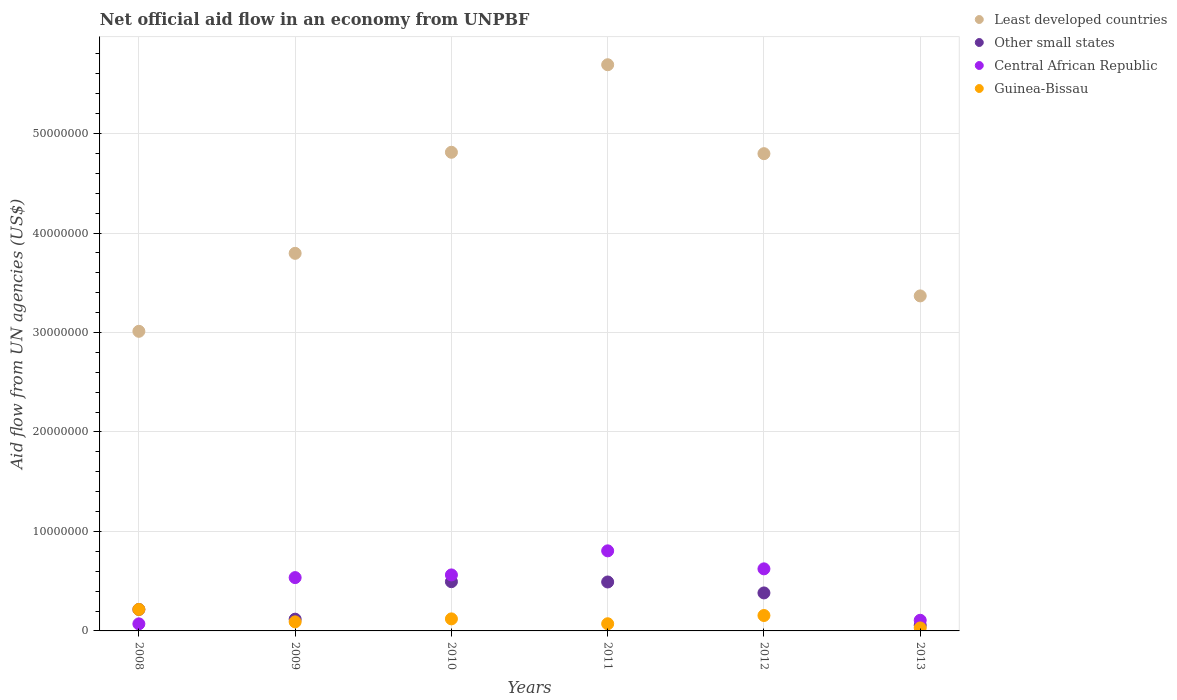What is the net official aid flow in Other small states in 2010?
Your answer should be very brief. 4.95e+06. Across all years, what is the maximum net official aid flow in Least developed countries?
Provide a succinct answer. 5.69e+07. Across all years, what is the minimum net official aid flow in Guinea-Bissau?
Offer a very short reply. 3.00e+05. In which year was the net official aid flow in Other small states minimum?
Give a very brief answer. 2013. What is the total net official aid flow in Guinea-Bissau in the graph?
Keep it short and to the point. 6.85e+06. What is the difference between the net official aid flow in Central African Republic in 2008 and that in 2012?
Offer a very short reply. -5.53e+06. What is the difference between the net official aid flow in Other small states in 2010 and the net official aid flow in Guinea-Bissau in 2009?
Your answer should be compact. 4.04e+06. What is the average net official aid flow in Other small states per year?
Offer a very short reply. 2.93e+06. In the year 2010, what is the difference between the net official aid flow in Least developed countries and net official aid flow in Central African Republic?
Your answer should be compact. 4.25e+07. What is the ratio of the net official aid flow in Guinea-Bissau in 2011 to that in 2012?
Keep it short and to the point. 0.46. Is the net official aid flow in Least developed countries in 2008 less than that in 2013?
Make the answer very short. Yes. What is the difference between the highest and the second highest net official aid flow in Least developed countries?
Give a very brief answer. 8.80e+06. What is the difference between the highest and the lowest net official aid flow in Least developed countries?
Your answer should be compact. 2.68e+07. In how many years, is the net official aid flow in Central African Republic greater than the average net official aid flow in Central African Republic taken over all years?
Offer a very short reply. 4. Is the sum of the net official aid flow in Guinea-Bissau in 2009 and 2013 greater than the maximum net official aid flow in Other small states across all years?
Keep it short and to the point. No. Is it the case that in every year, the sum of the net official aid flow in Central African Republic and net official aid flow in Other small states  is greater than the sum of net official aid flow in Least developed countries and net official aid flow in Guinea-Bissau?
Ensure brevity in your answer.  No. Does the net official aid flow in Least developed countries monotonically increase over the years?
Provide a short and direct response. No. Is the net official aid flow in Other small states strictly less than the net official aid flow in Guinea-Bissau over the years?
Keep it short and to the point. No. What is the difference between two consecutive major ticks on the Y-axis?
Ensure brevity in your answer.  1.00e+07. Are the values on the major ticks of Y-axis written in scientific E-notation?
Your answer should be very brief. No. How many legend labels are there?
Your answer should be very brief. 4. What is the title of the graph?
Provide a short and direct response. Net official aid flow in an economy from UNPBF. What is the label or title of the Y-axis?
Offer a terse response. Aid flow from UN agencies (US$). What is the Aid flow from UN agencies (US$) of Least developed countries in 2008?
Your answer should be compact. 3.01e+07. What is the Aid flow from UN agencies (US$) of Other small states in 2008?
Your answer should be compact. 2.16e+06. What is the Aid flow from UN agencies (US$) of Central African Republic in 2008?
Provide a succinct answer. 7.10e+05. What is the Aid flow from UN agencies (US$) in Guinea-Bissau in 2008?
Your answer should be compact. 2.16e+06. What is the Aid flow from UN agencies (US$) of Least developed countries in 2009?
Offer a very short reply. 3.80e+07. What is the Aid flow from UN agencies (US$) of Other small states in 2009?
Ensure brevity in your answer.  1.18e+06. What is the Aid flow from UN agencies (US$) of Central African Republic in 2009?
Keep it short and to the point. 5.36e+06. What is the Aid flow from UN agencies (US$) of Guinea-Bissau in 2009?
Keep it short and to the point. 9.10e+05. What is the Aid flow from UN agencies (US$) in Least developed countries in 2010?
Provide a succinct answer. 4.81e+07. What is the Aid flow from UN agencies (US$) in Other small states in 2010?
Provide a short and direct response. 4.95e+06. What is the Aid flow from UN agencies (US$) in Central African Republic in 2010?
Make the answer very short. 5.63e+06. What is the Aid flow from UN agencies (US$) in Guinea-Bissau in 2010?
Your answer should be compact. 1.21e+06. What is the Aid flow from UN agencies (US$) in Least developed countries in 2011?
Provide a short and direct response. 5.69e+07. What is the Aid flow from UN agencies (US$) of Other small states in 2011?
Give a very brief answer. 4.92e+06. What is the Aid flow from UN agencies (US$) in Central African Republic in 2011?
Keep it short and to the point. 8.05e+06. What is the Aid flow from UN agencies (US$) in Guinea-Bissau in 2011?
Offer a terse response. 7.20e+05. What is the Aid flow from UN agencies (US$) of Least developed countries in 2012?
Your response must be concise. 4.80e+07. What is the Aid flow from UN agencies (US$) in Other small states in 2012?
Offer a terse response. 3.82e+06. What is the Aid flow from UN agencies (US$) in Central African Republic in 2012?
Your answer should be very brief. 6.24e+06. What is the Aid flow from UN agencies (US$) of Guinea-Bissau in 2012?
Your answer should be very brief. 1.55e+06. What is the Aid flow from UN agencies (US$) of Least developed countries in 2013?
Keep it short and to the point. 3.37e+07. What is the Aid flow from UN agencies (US$) of Other small states in 2013?
Offer a terse response. 5.70e+05. What is the Aid flow from UN agencies (US$) of Central African Republic in 2013?
Give a very brief answer. 1.07e+06. Across all years, what is the maximum Aid flow from UN agencies (US$) in Least developed countries?
Offer a terse response. 5.69e+07. Across all years, what is the maximum Aid flow from UN agencies (US$) of Other small states?
Your response must be concise. 4.95e+06. Across all years, what is the maximum Aid flow from UN agencies (US$) in Central African Republic?
Your answer should be compact. 8.05e+06. Across all years, what is the maximum Aid flow from UN agencies (US$) in Guinea-Bissau?
Offer a terse response. 2.16e+06. Across all years, what is the minimum Aid flow from UN agencies (US$) of Least developed countries?
Keep it short and to the point. 3.01e+07. Across all years, what is the minimum Aid flow from UN agencies (US$) in Other small states?
Make the answer very short. 5.70e+05. Across all years, what is the minimum Aid flow from UN agencies (US$) in Central African Republic?
Your answer should be very brief. 7.10e+05. What is the total Aid flow from UN agencies (US$) of Least developed countries in the graph?
Keep it short and to the point. 2.55e+08. What is the total Aid flow from UN agencies (US$) in Other small states in the graph?
Give a very brief answer. 1.76e+07. What is the total Aid flow from UN agencies (US$) of Central African Republic in the graph?
Your answer should be compact. 2.71e+07. What is the total Aid flow from UN agencies (US$) in Guinea-Bissau in the graph?
Make the answer very short. 6.85e+06. What is the difference between the Aid flow from UN agencies (US$) of Least developed countries in 2008 and that in 2009?
Provide a short and direct response. -7.84e+06. What is the difference between the Aid flow from UN agencies (US$) in Other small states in 2008 and that in 2009?
Your answer should be very brief. 9.80e+05. What is the difference between the Aid flow from UN agencies (US$) of Central African Republic in 2008 and that in 2009?
Give a very brief answer. -4.65e+06. What is the difference between the Aid flow from UN agencies (US$) of Guinea-Bissau in 2008 and that in 2009?
Ensure brevity in your answer.  1.25e+06. What is the difference between the Aid flow from UN agencies (US$) of Least developed countries in 2008 and that in 2010?
Keep it short and to the point. -1.80e+07. What is the difference between the Aid flow from UN agencies (US$) in Other small states in 2008 and that in 2010?
Offer a terse response. -2.79e+06. What is the difference between the Aid flow from UN agencies (US$) in Central African Republic in 2008 and that in 2010?
Make the answer very short. -4.92e+06. What is the difference between the Aid flow from UN agencies (US$) of Guinea-Bissau in 2008 and that in 2010?
Provide a short and direct response. 9.50e+05. What is the difference between the Aid flow from UN agencies (US$) in Least developed countries in 2008 and that in 2011?
Offer a very short reply. -2.68e+07. What is the difference between the Aid flow from UN agencies (US$) in Other small states in 2008 and that in 2011?
Your answer should be compact. -2.76e+06. What is the difference between the Aid flow from UN agencies (US$) in Central African Republic in 2008 and that in 2011?
Your answer should be compact. -7.34e+06. What is the difference between the Aid flow from UN agencies (US$) of Guinea-Bissau in 2008 and that in 2011?
Provide a succinct answer. 1.44e+06. What is the difference between the Aid flow from UN agencies (US$) of Least developed countries in 2008 and that in 2012?
Offer a terse response. -1.79e+07. What is the difference between the Aid flow from UN agencies (US$) of Other small states in 2008 and that in 2012?
Provide a short and direct response. -1.66e+06. What is the difference between the Aid flow from UN agencies (US$) of Central African Republic in 2008 and that in 2012?
Give a very brief answer. -5.53e+06. What is the difference between the Aid flow from UN agencies (US$) in Least developed countries in 2008 and that in 2013?
Provide a short and direct response. -3.56e+06. What is the difference between the Aid flow from UN agencies (US$) of Other small states in 2008 and that in 2013?
Give a very brief answer. 1.59e+06. What is the difference between the Aid flow from UN agencies (US$) of Central African Republic in 2008 and that in 2013?
Make the answer very short. -3.60e+05. What is the difference between the Aid flow from UN agencies (US$) of Guinea-Bissau in 2008 and that in 2013?
Keep it short and to the point. 1.86e+06. What is the difference between the Aid flow from UN agencies (US$) of Least developed countries in 2009 and that in 2010?
Offer a very short reply. -1.02e+07. What is the difference between the Aid flow from UN agencies (US$) in Other small states in 2009 and that in 2010?
Give a very brief answer. -3.77e+06. What is the difference between the Aid flow from UN agencies (US$) of Least developed countries in 2009 and that in 2011?
Your response must be concise. -1.90e+07. What is the difference between the Aid flow from UN agencies (US$) in Other small states in 2009 and that in 2011?
Your answer should be very brief. -3.74e+06. What is the difference between the Aid flow from UN agencies (US$) of Central African Republic in 2009 and that in 2011?
Provide a short and direct response. -2.69e+06. What is the difference between the Aid flow from UN agencies (US$) of Guinea-Bissau in 2009 and that in 2011?
Give a very brief answer. 1.90e+05. What is the difference between the Aid flow from UN agencies (US$) of Least developed countries in 2009 and that in 2012?
Your response must be concise. -1.00e+07. What is the difference between the Aid flow from UN agencies (US$) of Other small states in 2009 and that in 2012?
Provide a succinct answer. -2.64e+06. What is the difference between the Aid flow from UN agencies (US$) in Central African Republic in 2009 and that in 2012?
Offer a terse response. -8.80e+05. What is the difference between the Aid flow from UN agencies (US$) in Guinea-Bissau in 2009 and that in 2012?
Your response must be concise. -6.40e+05. What is the difference between the Aid flow from UN agencies (US$) in Least developed countries in 2009 and that in 2013?
Provide a short and direct response. 4.28e+06. What is the difference between the Aid flow from UN agencies (US$) in Other small states in 2009 and that in 2013?
Provide a succinct answer. 6.10e+05. What is the difference between the Aid flow from UN agencies (US$) in Central African Republic in 2009 and that in 2013?
Your answer should be very brief. 4.29e+06. What is the difference between the Aid flow from UN agencies (US$) of Guinea-Bissau in 2009 and that in 2013?
Offer a terse response. 6.10e+05. What is the difference between the Aid flow from UN agencies (US$) in Least developed countries in 2010 and that in 2011?
Provide a succinct answer. -8.80e+06. What is the difference between the Aid flow from UN agencies (US$) of Central African Republic in 2010 and that in 2011?
Your answer should be very brief. -2.42e+06. What is the difference between the Aid flow from UN agencies (US$) of Guinea-Bissau in 2010 and that in 2011?
Provide a succinct answer. 4.90e+05. What is the difference between the Aid flow from UN agencies (US$) of Least developed countries in 2010 and that in 2012?
Offer a very short reply. 1.40e+05. What is the difference between the Aid flow from UN agencies (US$) in Other small states in 2010 and that in 2012?
Provide a succinct answer. 1.13e+06. What is the difference between the Aid flow from UN agencies (US$) of Central African Republic in 2010 and that in 2012?
Your response must be concise. -6.10e+05. What is the difference between the Aid flow from UN agencies (US$) of Guinea-Bissau in 2010 and that in 2012?
Keep it short and to the point. -3.40e+05. What is the difference between the Aid flow from UN agencies (US$) of Least developed countries in 2010 and that in 2013?
Offer a very short reply. 1.44e+07. What is the difference between the Aid flow from UN agencies (US$) in Other small states in 2010 and that in 2013?
Make the answer very short. 4.38e+06. What is the difference between the Aid flow from UN agencies (US$) in Central African Republic in 2010 and that in 2013?
Your response must be concise. 4.56e+06. What is the difference between the Aid flow from UN agencies (US$) in Guinea-Bissau in 2010 and that in 2013?
Your response must be concise. 9.10e+05. What is the difference between the Aid flow from UN agencies (US$) of Least developed countries in 2011 and that in 2012?
Your response must be concise. 8.94e+06. What is the difference between the Aid flow from UN agencies (US$) of Other small states in 2011 and that in 2012?
Make the answer very short. 1.10e+06. What is the difference between the Aid flow from UN agencies (US$) of Central African Republic in 2011 and that in 2012?
Offer a very short reply. 1.81e+06. What is the difference between the Aid flow from UN agencies (US$) of Guinea-Bissau in 2011 and that in 2012?
Your answer should be compact. -8.30e+05. What is the difference between the Aid flow from UN agencies (US$) in Least developed countries in 2011 and that in 2013?
Make the answer very short. 2.32e+07. What is the difference between the Aid flow from UN agencies (US$) in Other small states in 2011 and that in 2013?
Your answer should be compact. 4.35e+06. What is the difference between the Aid flow from UN agencies (US$) in Central African Republic in 2011 and that in 2013?
Your answer should be very brief. 6.98e+06. What is the difference between the Aid flow from UN agencies (US$) in Guinea-Bissau in 2011 and that in 2013?
Keep it short and to the point. 4.20e+05. What is the difference between the Aid flow from UN agencies (US$) of Least developed countries in 2012 and that in 2013?
Your response must be concise. 1.43e+07. What is the difference between the Aid flow from UN agencies (US$) of Other small states in 2012 and that in 2013?
Provide a short and direct response. 3.25e+06. What is the difference between the Aid flow from UN agencies (US$) of Central African Republic in 2012 and that in 2013?
Provide a succinct answer. 5.17e+06. What is the difference between the Aid flow from UN agencies (US$) in Guinea-Bissau in 2012 and that in 2013?
Provide a short and direct response. 1.25e+06. What is the difference between the Aid flow from UN agencies (US$) of Least developed countries in 2008 and the Aid flow from UN agencies (US$) of Other small states in 2009?
Provide a succinct answer. 2.89e+07. What is the difference between the Aid flow from UN agencies (US$) in Least developed countries in 2008 and the Aid flow from UN agencies (US$) in Central African Republic in 2009?
Provide a succinct answer. 2.48e+07. What is the difference between the Aid flow from UN agencies (US$) of Least developed countries in 2008 and the Aid flow from UN agencies (US$) of Guinea-Bissau in 2009?
Make the answer very short. 2.92e+07. What is the difference between the Aid flow from UN agencies (US$) of Other small states in 2008 and the Aid flow from UN agencies (US$) of Central African Republic in 2009?
Your response must be concise. -3.20e+06. What is the difference between the Aid flow from UN agencies (US$) in Other small states in 2008 and the Aid flow from UN agencies (US$) in Guinea-Bissau in 2009?
Your answer should be compact. 1.25e+06. What is the difference between the Aid flow from UN agencies (US$) in Least developed countries in 2008 and the Aid flow from UN agencies (US$) in Other small states in 2010?
Your response must be concise. 2.52e+07. What is the difference between the Aid flow from UN agencies (US$) of Least developed countries in 2008 and the Aid flow from UN agencies (US$) of Central African Republic in 2010?
Your answer should be very brief. 2.45e+07. What is the difference between the Aid flow from UN agencies (US$) of Least developed countries in 2008 and the Aid flow from UN agencies (US$) of Guinea-Bissau in 2010?
Offer a very short reply. 2.89e+07. What is the difference between the Aid flow from UN agencies (US$) in Other small states in 2008 and the Aid flow from UN agencies (US$) in Central African Republic in 2010?
Offer a very short reply. -3.47e+06. What is the difference between the Aid flow from UN agencies (US$) of Other small states in 2008 and the Aid flow from UN agencies (US$) of Guinea-Bissau in 2010?
Offer a terse response. 9.50e+05. What is the difference between the Aid flow from UN agencies (US$) in Central African Republic in 2008 and the Aid flow from UN agencies (US$) in Guinea-Bissau in 2010?
Keep it short and to the point. -5.00e+05. What is the difference between the Aid flow from UN agencies (US$) in Least developed countries in 2008 and the Aid flow from UN agencies (US$) in Other small states in 2011?
Offer a terse response. 2.52e+07. What is the difference between the Aid flow from UN agencies (US$) in Least developed countries in 2008 and the Aid flow from UN agencies (US$) in Central African Republic in 2011?
Offer a very short reply. 2.21e+07. What is the difference between the Aid flow from UN agencies (US$) of Least developed countries in 2008 and the Aid flow from UN agencies (US$) of Guinea-Bissau in 2011?
Provide a short and direct response. 2.94e+07. What is the difference between the Aid flow from UN agencies (US$) in Other small states in 2008 and the Aid flow from UN agencies (US$) in Central African Republic in 2011?
Keep it short and to the point. -5.89e+06. What is the difference between the Aid flow from UN agencies (US$) of Other small states in 2008 and the Aid flow from UN agencies (US$) of Guinea-Bissau in 2011?
Give a very brief answer. 1.44e+06. What is the difference between the Aid flow from UN agencies (US$) of Central African Republic in 2008 and the Aid flow from UN agencies (US$) of Guinea-Bissau in 2011?
Your response must be concise. -10000. What is the difference between the Aid flow from UN agencies (US$) of Least developed countries in 2008 and the Aid flow from UN agencies (US$) of Other small states in 2012?
Make the answer very short. 2.63e+07. What is the difference between the Aid flow from UN agencies (US$) in Least developed countries in 2008 and the Aid flow from UN agencies (US$) in Central African Republic in 2012?
Offer a very short reply. 2.39e+07. What is the difference between the Aid flow from UN agencies (US$) of Least developed countries in 2008 and the Aid flow from UN agencies (US$) of Guinea-Bissau in 2012?
Your answer should be very brief. 2.86e+07. What is the difference between the Aid flow from UN agencies (US$) in Other small states in 2008 and the Aid flow from UN agencies (US$) in Central African Republic in 2012?
Offer a terse response. -4.08e+06. What is the difference between the Aid flow from UN agencies (US$) of Other small states in 2008 and the Aid flow from UN agencies (US$) of Guinea-Bissau in 2012?
Ensure brevity in your answer.  6.10e+05. What is the difference between the Aid flow from UN agencies (US$) of Central African Republic in 2008 and the Aid flow from UN agencies (US$) of Guinea-Bissau in 2012?
Make the answer very short. -8.40e+05. What is the difference between the Aid flow from UN agencies (US$) in Least developed countries in 2008 and the Aid flow from UN agencies (US$) in Other small states in 2013?
Your answer should be compact. 2.96e+07. What is the difference between the Aid flow from UN agencies (US$) of Least developed countries in 2008 and the Aid flow from UN agencies (US$) of Central African Republic in 2013?
Your answer should be compact. 2.90e+07. What is the difference between the Aid flow from UN agencies (US$) in Least developed countries in 2008 and the Aid flow from UN agencies (US$) in Guinea-Bissau in 2013?
Offer a terse response. 2.98e+07. What is the difference between the Aid flow from UN agencies (US$) in Other small states in 2008 and the Aid flow from UN agencies (US$) in Central African Republic in 2013?
Ensure brevity in your answer.  1.09e+06. What is the difference between the Aid flow from UN agencies (US$) of Other small states in 2008 and the Aid flow from UN agencies (US$) of Guinea-Bissau in 2013?
Provide a succinct answer. 1.86e+06. What is the difference between the Aid flow from UN agencies (US$) in Central African Republic in 2008 and the Aid flow from UN agencies (US$) in Guinea-Bissau in 2013?
Your answer should be compact. 4.10e+05. What is the difference between the Aid flow from UN agencies (US$) in Least developed countries in 2009 and the Aid flow from UN agencies (US$) in Other small states in 2010?
Provide a succinct answer. 3.30e+07. What is the difference between the Aid flow from UN agencies (US$) of Least developed countries in 2009 and the Aid flow from UN agencies (US$) of Central African Republic in 2010?
Give a very brief answer. 3.23e+07. What is the difference between the Aid flow from UN agencies (US$) of Least developed countries in 2009 and the Aid flow from UN agencies (US$) of Guinea-Bissau in 2010?
Give a very brief answer. 3.68e+07. What is the difference between the Aid flow from UN agencies (US$) of Other small states in 2009 and the Aid flow from UN agencies (US$) of Central African Republic in 2010?
Your answer should be very brief. -4.45e+06. What is the difference between the Aid flow from UN agencies (US$) of Central African Republic in 2009 and the Aid flow from UN agencies (US$) of Guinea-Bissau in 2010?
Offer a very short reply. 4.15e+06. What is the difference between the Aid flow from UN agencies (US$) in Least developed countries in 2009 and the Aid flow from UN agencies (US$) in Other small states in 2011?
Your answer should be very brief. 3.30e+07. What is the difference between the Aid flow from UN agencies (US$) in Least developed countries in 2009 and the Aid flow from UN agencies (US$) in Central African Republic in 2011?
Make the answer very short. 2.99e+07. What is the difference between the Aid flow from UN agencies (US$) of Least developed countries in 2009 and the Aid flow from UN agencies (US$) of Guinea-Bissau in 2011?
Provide a succinct answer. 3.72e+07. What is the difference between the Aid flow from UN agencies (US$) in Other small states in 2009 and the Aid flow from UN agencies (US$) in Central African Republic in 2011?
Provide a succinct answer. -6.87e+06. What is the difference between the Aid flow from UN agencies (US$) of Other small states in 2009 and the Aid flow from UN agencies (US$) of Guinea-Bissau in 2011?
Your answer should be compact. 4.60e+05. What is the difference between the Aid flow from UN agencies (US$) of Central African Republic in 2009 and the Aid flow from UN agencies (US$) of Guinea-Bissau in 2011?
Offer a terse response. 4.64e+06. What is the difference between the Aid flow from UN agencies (US$) of Least developed countries in 2009 and the Aid flow from UN agencies (US$) of Other small states in 2012?
Provide a short and direct response. 3.41e+07. What is the difference between the Aid flow from UN agencies (US$) of Least developed countries in 2009 and the Aid flow from UN agencies (US$) of Central African Republic in 2012?
Your answer should be compact. 3.17e+07. What is the difference between the Aid flow from UN agencies (US$) of Least developed countries in 2009 and the Aid flow from UN agencies (US$) of Guinea-Bissau in 2012?
Give a very brief answer. 3.64e+07. What is the difference between the Aid flow from UN agencies (US$) of Other small states in 2009 and the Aid flow from UN agencies (US$) of Central African Republic in 2012?
Give a very brief answer. -5.06e+06. What is the difference between the Aid flow from UN agencies (US$) in Other small states in 2009 and the Aid flow from UN agencies (US$) in Guinea-Bissau in 2012?
Make the answer very short. -3.70e+05. What is the difference between the Aid flow from UN agencies (US$) in Central African Republic in 2009 and the Aid flow from UN agencies (US$) in Guinea-Bissau in 2012?
Your response must be concise. 3.81e+06. What is the difference between the Aid flow from UN agencies (US$) in Least developed countries in 2009 and the Aid flow from UN agencies (US$) in Other small states in 2013?
Make the answer very short. 3.74e+07. What is the difference between the Aid flow from UN agencies (US$) of Least developed countries in 2009 and the Aid flow from UN agencies (US$) of Central African Republic in 2013?
Ensure brevity in your answer.  3.69e+07. What is the difference between the Aid flow from UN agencies (US$) in Least developed countries in 2009 and the Aid flow from UN agencies (US$) in Guinea-Bissau in 2013?
Give a very brief answer. 3.77e+07. What is the difference between the Aid flow from UN agencies (US$) of Other small states in 2009 and the Aid flow from UN agencies (US$) of Central African Republic in 2013?
Offer a very short reply. 1.10e+05. What is the difference between the Aid flow from UN agencies (US$) in Other small states in 2009 and the Aid flow from UN agencies (US$) in Guinea-Bissau in 2013?
Offer a very short reply. 8.80e+05. What is the difference between the Aid flow from UN agencies (US$) of Central African Republic in 2009 and the Aid flow from UN agencies (US$) of Guinea-Bissau in 2013?
Your response must be concise. 5.06e+06. What is the difference between the Aid flow from UN agencies (US$) of Least developed countries in 2010 and the Aid flow from UN agencies (US$) of Other small states in 2011?
Your response must be concise. 4.32e+07. What is the difference between the Aid flow from UN agencies (US$) of Least developed countries in 2010 and the Aid flow from UN agencies (US$) of Central African Republic in 2011?
Ensure brevity in your answer.  4.01e+07. What is the difference between the Aid flow from UN agencies (US$) in Least developed countries in 2010 and the Aid flow from UN agencies (US$) in Guinea-Bissau in 2011?
Your answer should be very brief. 4.74e+07. What is the difference between the Aid flow from UN agencies (US$) of Other small states in 2010 and the Aid flow from UN agencies (US$) of Central African Republic in 2011?
Offer a very short reply. -3.10e+06. What is the difference between the Aid flow from UN agencies (US$) of Other small states in 2010 and the Aid flow from UN agencies (US$) of Guinea-Bissau in 2011?
Your response must be concise. 4.23e+06. What is the difference between the Aid flow from UN agencies (US$) in Central African Republic in 2010 and the Aid flow from UN agencies (US$) in Guinea-Bissau in 2011?
Your answer should be compact. 4.91e+06. What is the difference between the Aid flow from UN agencies (US$) of Least developed countries in 2010 and the Aid flow from UN agencies (US$) of Other small states in 2012?
Your answer should be compact. 4.43e+07. What is the difference between the Aid flow from UN agencies (US$) of Least developed countries in 2010 and the Aid flow from UN agencies (US$) of Central African Republic in 2012?
Offer a very short reply. 4.19e+07. What is the difference between the Aid flow from UN agencies (US$) of Least developed countries in 2010 and the Aid flow from UN agencies (US$) of Guinea-Bissau in 2012?
Offer a terse response. 4.66e+07. What is the difference between the Aid flow from UN agencies (US$) of Other small states in 2010 and the Aid flow from UN agencies (US$) of Central African Republic in 2012?
Offer a very short reply. -1.29e+06. What is the difference between the Aid flow from UN agencies (US$) in Other small states in 2010 and the Aid flow from UN agencies (US$) in Guinea-Bissau in 2012?
Keep it short and to the point. 3.40e+06. What is the difference between the Aid flow from UN agencies (US$) in Central African Republic in 2010 and the Aid flow from UN agencies (US$) in Guinea-Bissau in 2012?
Offer a terse response. 4.08e+06. What is the difference between the Aid flow from UN agencies (US$) in Least developed countries in 2010 and the Aid flow from UN agencies (US$) in Other small states in 2013?
Offer a terse response. 4.76e+07. What is the difference between the Aid flow from UN agencies (US$) of Least developed countries in 2010 and the Aid flow from UN agencies (US$) of Central African Republic in 2013?
Provide a succinct answer. 4.70e+07. What is the difference between the Aid flow from UN agencies (US$) in Least developed countries in 2010 and the Aid flow from UN agencies (US$) in Guinea-Bissau in 2013?
Provide a short and direct response. 4.78e+07. What is the difference between the Aid flow from UN agencies (US$) of Other small states in 2010 and the Aid flow from UN agencies (US$) of Central African Republic in 2013?
Provide a short and direct response. 3.88e+06. What is the difference between the Aid flow from UN agencies (US$) in Other small states in 2010 and the Aid flow from UN agencies (US$) in Guinea-Bissau in 2013?
Offer a very short reply. 4.65e+06. What is the difference between the Aid flow from UN agencies (US$) in Central African Republic in 2010 and the Aid flow from UN agencies (US$) in Guinea-Bissau in 2013?
Your answer should be very brief. 5.33e+06. What is the difference between the Aid flow from UN agencies (US$) of Least developed countries in 2011 and the Aid flow from UN agencies (US$) of Other small states in 2012?
Offer a terse response. 5.31e+07. What is the difference between the Aid flow from UN agencies (US$) in Least developed countries in 2011 and the Aid flow from UN agencies (US$) in Central African Republic in 2012?
Offer a very short reply. 5.07e+07. What is the difference between the Aid flow from UN agencies (US$) of Least developed countries in 2011 and the Aid flow from UN agencies (US$) of Guinea-Bissau in 2012?
Your answer should be compact. 5.54e+07. What is the difference between the Aid flow from UN agencies (US$) in Other small states in 2011 and the Aid flow from UN agencies (US$) in Central African Republic in 2012?
Offer a terse response. -1.32e+06. What is the difference between the Aid flow from UN agencies (US$) of Other small states in 2011 and the Aid flow from UN agencies (US$) of Guinea-Bissau in 2012?
Your answer should be compact. 3.37e+06. What is the difference between the Aid flow from UN agencies (US$) in Central African Republic in 2011 and the Aid flow from UN agencies (US$) in Guinea-Bissau in 2012?
Give a very brief answer. 6.50e+06. What is the difference between the Aid flow from UN agencies (US$) of Least developed countries in 2011 and the Aid flow from UN agencies (US$) of Other small states in 2013?
Provide a short and direct response. 5.64e+07. What is the difference between the Aid flow from UN agencies (US$) of Least developed countries in 2011 and the Aid flow from UN agencies (US$) of Central African Republic in 2013?
Offer a terse response. 5.58e+07. What is the difference between the Aid flow from UN agencies (US$) in Least developed countries in 2011 and the Aid flow from UN agencies (US$) in Guinea-Bissau in 2013?
Ensure brevity in your answer.  5.66e+07. What is the difference between the Aid flow from UN agencies (US$) in Other small states in 2011 and the Aid flow from UN agencies (US$) in Central African Republic in 2013?
Offer a very short reply. 3.85e+06. What is the difference between the Aid flow from UN agencies (US$) in Other small states in 2011 and the Aid flow from UN agencies (US$) in Guinea-Bissau in 2013?
Keep it short and to the point. 4.62e+06. What is the difference between the Aid flow from UN agencies (US$) in Central African Republic in 2011 and the Aid flow from UN agencies (US$) in Guinea-Bissau in 2013?
Keep it short and to the point. 7.75e+06. What is the difference between the Aid flow from UN agencies (US$) of Least developed countries in 2012 and the Aid flow from UN agencies (US$) of Other small states in 2013?
Your answer should be compact. 4.74e+07. What is the difference between the Aid flow from UN agencies (US$) in Least developed countries in 2012 and the Aid flow from UN agencies (US$) in Central African Republic in 2013?
Your response must be concise. 4.69e+07. What is the difference between the Aid flow from UN agencies (US$) of Least developed countries in 2012 and the Aid flow from UN agencies (US$) of Guinea-Bissau in 2013?
Your response must be concise. 4.77e+07. What is the difference between the Aid flow from UN agencies (US$) of Other small states in 2012 and the Aid flow from UN agencies (US$) of Central African Republic in 2013?
Provide a succinct answer. 2.75e+06. What is the difference between the Aid flow from UN agencies (US$) in Other small states in 2012 and the Aid flow from UN agencies (US$) in Guinea-Bissau in 2013?
Provide a succinct answer. 3.52e+06. What is the difference between the Aid flow from UN agencies (US$) in Central African Republic in 2012 and the Aid flow from UN agencies (US$) in Guinea-Bissau in 2013?
Your response must be concise. 5.94e+06. What is the average Aid flow from UN agencies (US$) of Least developed countries per year?
Provide a short and direct response. 4.25e+07. What is the average Aid flow from UN agencies (US$) in Other small states per year?
Your answer should be very brief. 2.93e+06. What is the average Aid flow from UN agencies (US$) in Central African Republic per year?
Keep it short and to the point. 4.51e+06. What is the average Aid flow from UN agencies (US$) of Guinea-Bissau per year?
Offer a terse response. 1.14e+06. In the year 2008, what is the difference between the Aid flow from UN agencies (US$) of Least developed countries and Aid flow from UN agencies (US$) of Other small states?
Ensure brevity in your answer.  2.80e+07. In the year 2008, what is the difference between the Aid flow from UN agencies (US$) in Least developed countries and Aid flow from UN agencies (US$) in Central African Republic?
Your response must be concise. 2.94e+07. In the year 2008, what is the difference between the Aid flow from UN agencies (US$) of Least developed countries and Aid flow from UN agencies (US$) of Guinea-Bissau?
Give a very brief answer. 2.80e+07. In the year 2008, what is the difference between the Aid flow from UN agencies (US$) in Other small states and Aid flow from UN agencies (US$) in Central African Republic?
Keep it short and to the point. 1.45e+06. In the year 2008, what is the difference between the Aid flow from UN agencies (US$) in Other small states and Aid flow from UN agencies (US$) in Guinea-Bissau?
Your response must be concise. 0. In the year 2008, what is the difference between the Aid flow from UN agencies (US$) in Central African Republic and Aid flow from UN agencies (US$) in Guinea-Bissau?
Your response must be concise. -1.45e+06. In the year 2009, what is the difference between the Aid flow from UN agencies (US$) of Least developed countries and Aid flow from UN agencies (US$) of Other small states?
Your answer should be very brief. 3.68e+07. In the year 2009, what is the difference between the Aid flow from UN agencies (US$) in Least developed countries and Aid flow from UN agencies (US$) in Central African Republic?
Offer a very short reply. 3.26e+07. In the year 2009, what is the difference between the Aid flow from UN agencies (US$) in Least developed countries and Aid flow from UN agencies (US$) in Guinea-Bissau?
Offer a terse response. 3.70e+07. In the year 2009, what is the difference between the Aid flow from UN agencies (US$) of Other small states and Aid flow from UN agencies (US$) of Central African Republic?
Offer a terse response. -4.18e+06. In the year 2009, what is the difference between the Aid flow from UN agencies (US$) in Other small states and Aid flow from UN agencies (US$) in Guinea-Bissau?
Make the answer very short. 2.70e+05. In the year 2009, what is the difference between the Aid flow from UN agencies (US$) of Central African Republic and Aid flow from UN agencies (US$) of Guinea-Bissau?
Keep it short and to the point. 4.45e+06. In the year 2010, what is the difference between the Aid flow from UN agencies (US$) of Least developed countries and Aid flow from UN agencies (US$) of Other small states?
Make the answer very short. 4.32e+07. In the year 2010, what is the difference between the Aid flow from UN agencies (US$) of Least developed countries and Aid flow from UN agencies (US$) of Central African Republic?
Give a very brief answer. 4.25e+07. In the year 2010, what is the difference between the Aid flow from UN agencies (US$) of Least developed countries and Aid flow from UN agencies (US$) of Guinea-Bissau?
Keep it short and to the point. 4.69e+07. In the year 2010, what is the difference between the Aid flow from UN agencies (US$) of Other small states and Aid flow from UN agencies (US$) of Central African Republic?
Give a very brief answer. -6.80e+05. In the year 2010, what is the difference between the Aid flow from UN agencies (US$) of Other small states and Aid flow from UN agencies (US$) of Guinea-Bissau?
Your response must be concise. 3.74e+06. In the year 2010, what is the difference between the Aid flow from UN agencies (US$) in Central African Republic and Aid flow from UN agencies (US$) in Guinea-Bissau?
Your response must be concise. 4.42e+06. In the year 2011, what is the difference between the Aid flow from UN agencies (US$) of Least developed countries and Aid flow from UN agencies (US$) of Other small states?
Your answer should be very brief. 5.20e+07. In the year 2011, what is the difference between the Aid flow from UN agencies (US$) of Least developed countries and Aid flow from UN agencies (US$) of Central African Republic?
Your answer should be compact. 4.89e+07. In the year 2011, what is the difference between the Aid flow from UN agencies (US$) of Least developed countries and Aid flow from UN agencies (US$) of Guinea-Bissau?
Your answer should be compact. 5.62e+07. In the year 2011, what is the difference between the Aid flow from UN agencies (US$) in Other small states and Aid flow from UN agencies (US$) in Central African Republic?
Provide a succinct answer. -3.13e+06. In the year 2011, what is the difference between the Aid flow from UN agencies (US$) in Other small states and Aid flow from UN agencies (US$) in Guinea-Bissau?
Make the answer very short. 4.20e+06. In the year 2011, what is the difference between the Aid flow from UN agencies (US$) of Central African Republic and Aid flow from UN agencies (US$) of Guinea-Bissau?
Your answer should be very brief. 7.33e+06. In the year 2012, what is the difference between the Aid flow from UN agencies (US$) in Least developed countries and Aid flow from UN agencies (US$) in Other small states?
Give a very brief answer. 4.42e+07. In the year 2012, what is the difference between the Aid flow from UN agencies (US$) of Least developed countries and Aid flow from UN agencies (US$) of Central African Republic?
Give a very brief answer. 4.17e+07. In the year 2012, what is the difference between the Aid flow from UN agencies (US$) in Least developed countries and Aid flow from UN agencies (US$) in Guinea-Bissau?
Your response must be concise. 4.64e+07. In the year 2012, what is the difference between the Aid flow from UN agencies (US$) of Other small states and Aid flow from UN agencies (US$) of Central African Republic?
Your answer should be very brief. -2.42e+06. In the year 2012, what is the difference between the Aid flow from UN agencies (US$) in Other small states and Aid flow from UN agencies (US$) in Guinea-Bissau?
Your response must be concise. 2.27e+06. In the year 2012, what is the difference between the Aid flow from UN agencies (US$) of Central African Republic and Aid flow from UN agencies (US$) of Guinea-Bissau?
Keep it short and to the point. 4.69e+06. In the year 2013, what is the difference between the Aid flow from UN agencies (US$) in Least developed countries and Aid flow from UN agencies (US$) in Other small states?
Keep it short and to the point. 3.31e+07. In the year 2013, what is the difference between the Aid flow from UN agencies (US$) in Least developed countries and Aid flow from UN agencies (US$) in Central African Republic?
Your response must be concise. 3.26e+07. In the year 2013, what is the difference between the Aid flow from UN agencies (US$) in Least developed countries and Aid flow from UN agencies (US$) in Guinea-Bissau?
Your answer should be very brief. 3.34e+07. In the year 2013, what is the difference between the Aid flow from UN agencies (US$) in Other small states and Aid flow from UN agencies (US$) in Central African Republic?
Make the answer very short. -5.00e+05. In the year 2013, what is the difference between the Aid flow from UN agencies (US$) of Central African Republic and Aid flow from UN agencies (US$) of Guinea-Bissau?
Make the answer very short. 7.70e+05. What is the ratio of the Aid flow from UN agencies (US$) of Least developed countries in 2008 to that in 2009?
Make the answer very short. 0.79. What is the ratio of the Aid flow from UN agencies (US$) in Other small states in 2008 to that in 2009?
Your response must be concise. 1.83. What is the ratio of the Aid flow from UN agencies (US$) of Central African Republic in 2008 to that in 2009?
Keep it short and to the point. 0.13. What is the ratio of the Aid flow from UN agencies (US$) in Guinea-Bissau in 2008 to that in 2009?
Offer a very short reply. 2.37. What is the ratio of the Aid flow from UN agencies (US$) in Least developed countries in 2008 to that in 2010?
Your response must be concise. 0.63. What is the ratio of the Aid flow from UN agencies (US$) in Other small states in 2008 to that in 2010?
Make the answer very short. 0.44. What is the ratio of the Aid flow from UN agencies (US$) in Central African Republic in 2008 to that in 2010?
Provide a short and direct response. 0.13. What is the ratio of the Aid flow from UN agencies (US$) in Guinea-Bissau in 2008 to that in 2010?
Keep it short and to the point. 1.79. What is the ratio of the Aid flow from UN agencies (US$) in Least developed countries in 2008 to that in 2011?
Provide a short and direct response. 0.53. What is the ratio of the Aid flow from UN agencies (US$) in Other small states in 2008 to that in 2011?
Offer a very short reply. 0.44. What is the ratio of the Aid flow from UN agencies (US$) in Central African Republic in 2008 to that in 2011?
Your answer should be compact. 0.09. What is the ratio of the Aid flow from UN agencies (US$) in Least developed countries in 2008 to that in 2012?
Keep it short and to the point. 0.63. What is the ratio of the Aid flow from UN agencies (US$) in Other small states in 2008 to that in 2012?
Your answer should be very brief. 0.57. What is the ratio of the Aid flow from UN agencies (US$) of Central African Republic in 2008 to that in 2012?
Offer a very short reply. 0.11. What is the ratio of the Aid flow from UN agencies (US$) of Guinea-Bissau in 2008 to that in 2012?
Provide a short and direct response. 1.39. What is the ratio of the Aid flow from UN agencies (US$) in Least developed countries in 2008 to that in 2013?
Make the answer very short. 0.89. What is the ratio of the Aid flow from UN agencies (US$) of Other small states in 2008 to that in 2013?
Ensure brevity in your answer.  3.79. What is the ratio of the Aid flow from UN agencies (US$) in Central African Republic in 2008 to that in 2013?
Provide a succinct answer. 0.66. What is the ratio of the Aid flow from UN agencies (US$) in Least developed countries in 2009 to that in 2010?
Offer a terse response. 0.79. What is the ratio of the Aid flow from UN agencies (US$) in Other small states in 2009 to that in 2010?
Your answer should be very brief. 0.24. What is the ratio of the Aid flow from UN agencies (US$) in Central African Republic in 2009 to that in 2010?
Your answer should be compact. 0.95. What is the ratio of the Aid flow from UN agencies (US$) of Guinea-Bissau in 2009 to that in 2010?
Provide a succinct answer. 0.75. What is the ratio of the Aid flow from UN agencies (US$) of Least developed countries in 2009 to that in 2011?
Provide a succinct answer. 0.67. What is the ratio of the Aid flow from UN agencies (US$) of Other small states in 2009 to that in 2011?
Provide a succinct answer. 0.24. What is the ratio of the Aid flow from UN agencies (US$) of Central African Republic in 2009 to that in 2011?
Offer a very short reply. 0.67. What is the ratio of the Aid flow from UN agencies (US$) in Guinea-Bissau in 2009 to that in 2011?
Your answer should be compact. 1.26. What is the ratio of the Aid flow from UN agencies (US$) in Least developed countries in 2009 to that in 2012?
Make the answer very short. 0.79. What is the ratio of the Aid flow from UN agencies (US$) of Other small states in 2009 to that in 2012?
Keep it short and to the point. 0.31. What is the ratio of the Aid flow from UN agencies (US$) in Central African Republic in 2009 to that in 2012?
Give a very brief answer. 0.86. What is the ratio of the Aid flow from UN agencies (US$) in Guinea-Bissau in 2009 to that in 2012?
Offer a very short reply. 0.59. What is the ratio of the Aid flow from UN agencies (US$) of Least developed countries in 2009 to that in 2013?
Your answer should be compact. 1.13. What is the ratio of the Aid flow from UN agencies (US$) in Other small states in 2009 to that in 2013?
Give a very brief answer. 2.07. What is the ratio of the Aid flow from UN agencies (US$) of Central African Republic in 2009 to that in 2013?
Keep it short and to the point. 5.01. What is the ratio of the Aid flow from UN agencies (US$) in Guinea-Bissau in 2009 to that in 2013?
Offer a very short reply. 3.03. What is the ratio of the Aid flow from UN agencies (US$) in Least developed countries in 2010 to that in 2011?
Your response must be concise. 0.85. What is the ratio of the Aid flow from UN agencies (US$) of Central African Republic in 2010 to that in 2011?
Offer a very short reply. 0.7. What is the ratio of the Aid flow from UN agencies (US$) of Guinea-Bissau in 2010 to that in 2011?
Your answer should be compact. 1.68. What is the ratio of the Aid flow from UN agencies (US$) of Least developed countries in 2010 to that in 2012?
Make the answer very short. 1. What is the ratio of the Aid flow from UN agencies (US$) of Other small states in 2010 to that in 2012?
Offer a very short reply. 1.3. What is the ratio of the Aid flow from UN agencies (US$) of Central African Republic in 2010 to that in 2012?
Your answer should be compact. 0.9. What is the ratio of the Aid flow from UN agencies (US$) in Guinea-Bissau in 2010 to that in 2012?
Ensure brevity in your answer.  0.78. What is the ratio of the Aid flow from UN agencies (US$) of Least developed countries in 2010 to that in 2013?
Ensure brevity in your answer.  1.43. What is the ratio of the Aid flow from UN agencies (US$) in Other small states in 2010 to that in 2013?
Provide a short and direct response. 8.68. What is the ratio of the Aid flow from UN agencies (US$) of Central African Republic in 2010 to that in 2013?
Your answer should be very brief. 5.26. What is the ratio of the Aid flow from UN agencies (US$) of Guinea-Bissau in 2010 to that in 2013?
Offer a terse response. 4.03. What is the ratio of the Aid flow from UN agencies (US$) in Least developed countries in 2011 to that in 2012?
Ensure brevity in your answer.  1.19. What is the ratio of the Aid flow from UN agencies (US$) of Other small states in 2011 to that in 2012?
Ensure brevity in your answer.  1.29. What is the ratio of the Aid flow from UN agencies (US$) in Central African Republic in 2011 to that in 2012?
Provide a short and direct response. 1.29. What is the ratio of the Aid flow from UN agencies (US$) in Guinea-Bissau in 2011 to that in 2012?
Provide a short and direct response. 0.46. What is the ratio of the Aid flow from UN agencies (US$) of Least developed countries in 2011 to that in 2013?
Make the answer very short. 1.69. What is the ratio of the Aid flow from UN agencies (US$) of Other small states in 2011 to that in 2013?
Give a very brief answer. 8.63. What is the ratio of the Aid flow from UN agencies (US$) in Central African Republic in 2011 to that in 2013?
Offer a terse response. 7.52. What is the ratio of the Aid flow from UN agencies (US$) in Guinea-Bissau in 2011 to that in 2013?
Offer a very short reply. 2.4. What is the ratio of the Aid flow from UN agencies (US$) of Least developed countries in 2012 to that in 2013?
Your answer should be very brief. 1.42. What is the ratio of the Aid flow from UN agencies (US$) of Other small states in 2012 to that in 2013?
Provide a short and direct response. 6.7. What is the ratio of the Aid flow from UN agencies (US$) in Central African Republic in 2012 to that in 2013?
Keep it short and to the point. 5.83. What is the ratio of the Aid flow from UN agencies (US$) in Guinea-Bissau in 2012 to that in 2013?
Give a very brief answer. 5.17. What is the difference between the highest and the second highest Aid flow from UN agencies (US$) of Least developed countries?
Offer a very short reply. 8.80e+06. What is the difference between the highest and the second highest Aid flow from UN agencies (US$) of Central African Republic?
Offer a terse response. 1.81e+06. What is the difference between the highest and the lowest Aid flow from UN agencies (US$) of Least developed countries?
Provide a short and direct response. 2.68e+07. What is the difference between the highest and the lowest Aid flow from UN agencies (US$) of Other small states?
Offer a very short reply. 4.38e+06. What is the difference between the highest and the lowest Aid flow from UN agencies (US$) of Central African Republic?
Your answer should be very brief. 7.34e+06. What is the difference between the highest and the lowest Aid flow from UN agencies (US$) of Guinea-Bissau?
Keep it short and to the point. 1.86e+06. 